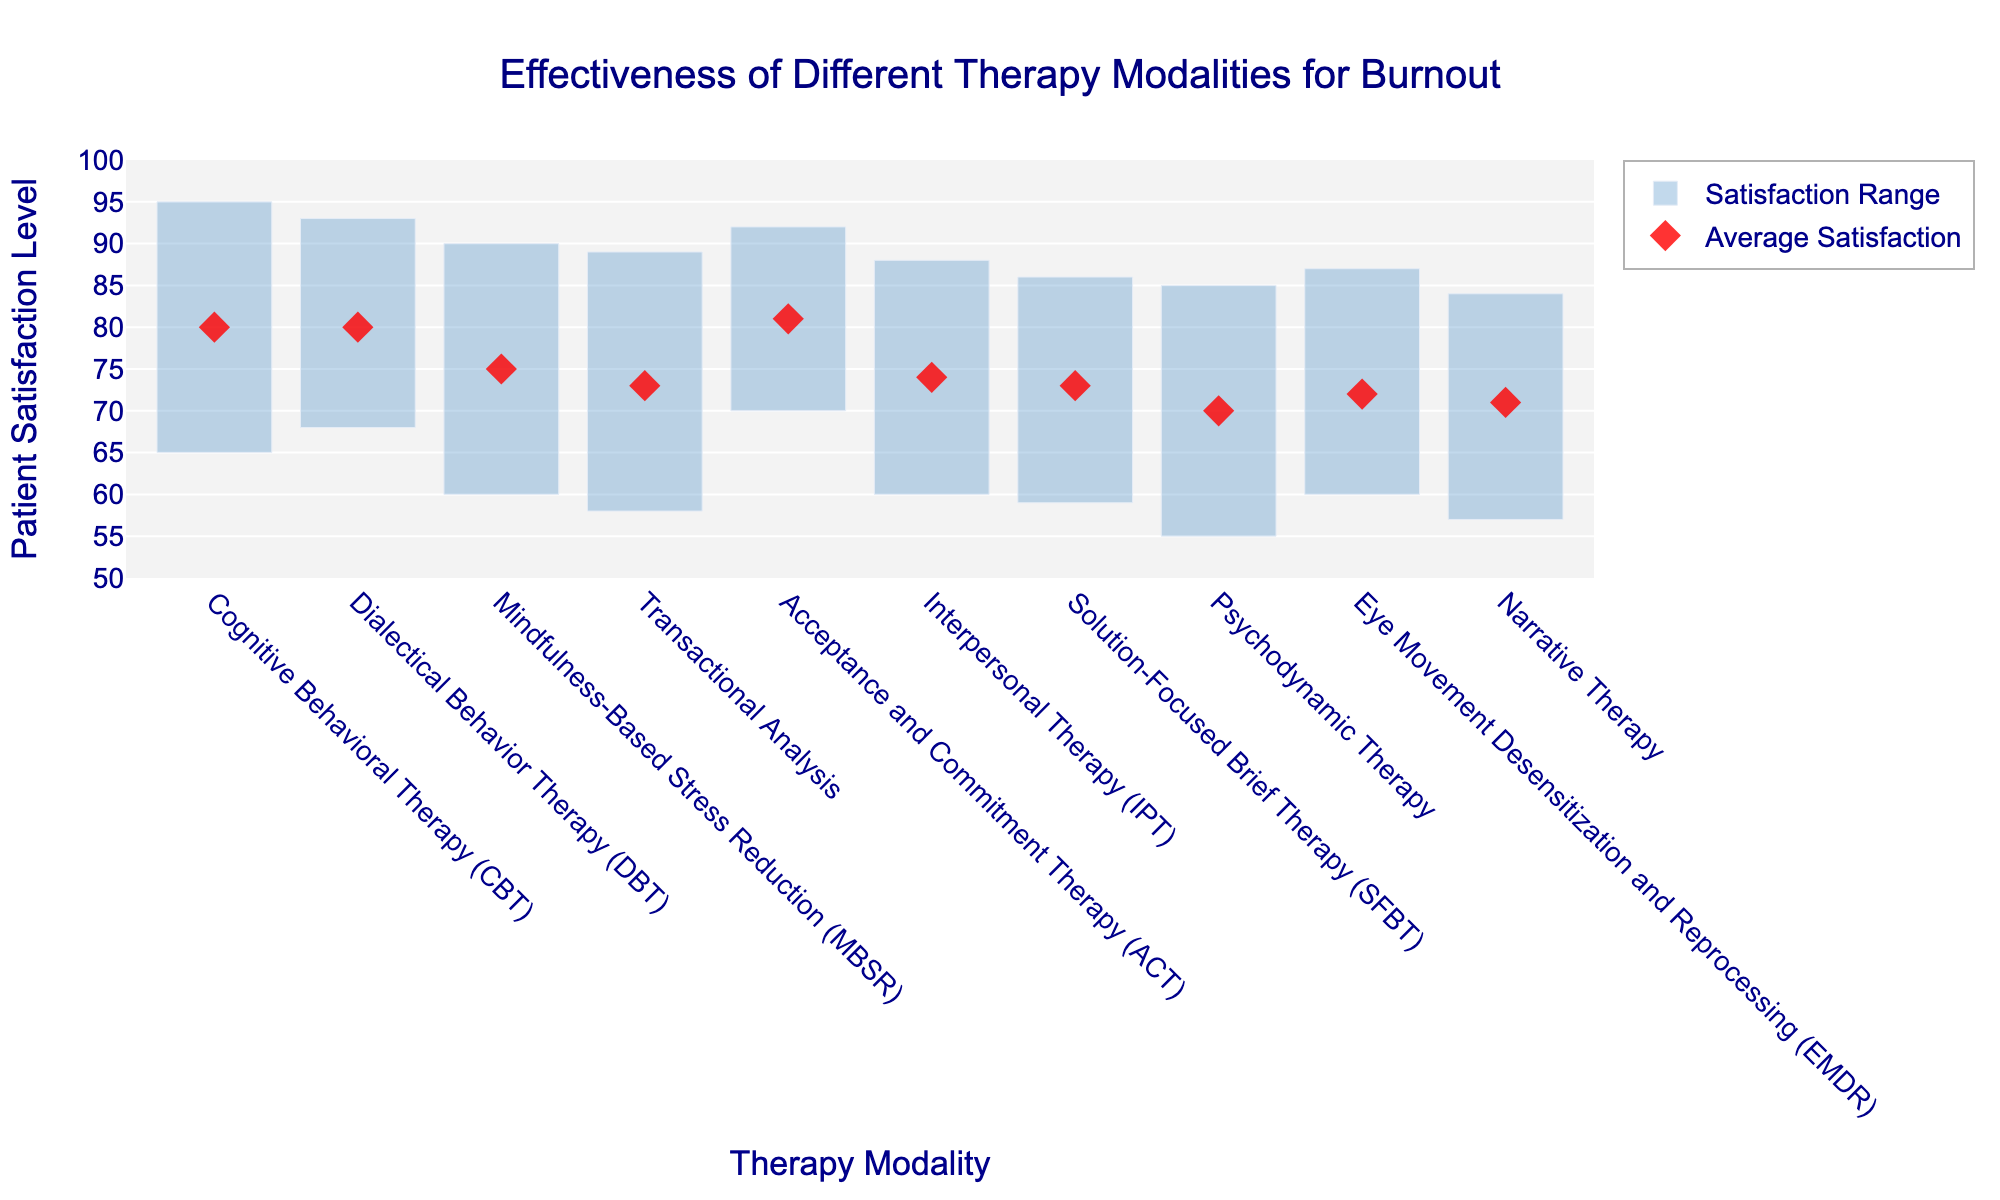what is the highest average satisfaction level among the therapy modalities? By looking at the chart, we can identify the therapy modality with the highest average satisfaction marker (red diamond). The highest average satisfaction level is associated with Acceptance and Commitment Therapy (ACT).
Answer: 81 What therapy modality has the widest range of patient satisfaction levels? The range of patient satisfaction levels is represented by the span of the blue bars. The widest range can be discerned by identifying the therapy with the longest bar. Mindfulness-Based Stress Reduction (MBSR) has the widest range of satisfaction levels.
Answer: Mindfulness-Based Stress Reduction (MBSR) Which therapy modality has the lowest minimum satisfaction level? The minimum satisfaction level is marked by the bottom of the blue bar for each therapy. The therapy with the lowest minimum satisfaction level is Psychodynamic Therapy with a minimum of 55.
Answer: Psychodynamic Therapy How does Cognitive Behavioral Therapy (CBT)’s average satisfaction compare to Interpersonal Therapy (IPT)’s average satisfaction? We locate the average satisfaction markers (red diamonds) for both Cognitive Behavioral Therapy (CBT) and Interpersonal Therapy (IPT). CBT has an average satisfaction level of 80, whereas IPT has an average satisfaction level of 74. Thus, CBT's average satisfaction is higher.
Answer: CBT's average is higher What is the difference between the maximum satisfaction levels of Dialectical Behavior Therapy (DBT) and Solution-Focused Brief Therapy (SFBT)? By examining the top of the blue bars, we find the maximum satisfaction levels: DBT is at 93 and SFBT is at 86. The difference between them is calculated as 93 - 86.
Answer: 7 Which therapy modalities have an average satisfaction level equal to 80? Average satisfaction levels are indicated by the red diamond markers. The therapies with a red diamond at the level 80 are Cognitive Behavioral Therapy (CBT) and Dialectical Behavior Therapy (DBT).
Answer: CBT and DBT What is the satisfaction range for Transactional Analysis? Find the bottom and top of the blue bar for Transactional Analysis; the min satisfaction is 58 and the max is 89. The range is calculated as 89 - 58.
Answer: 31 How many therapy modalities have a maximum satisfaction level of 90 or above? We count the number of therapy modalities with the top of their blue bars at or above the 90 level. These are Cognitive Behavioral Therapy (CBT), Acceptance and Commitment Therapy (ACT), Dialectical Behavior Therapy (DBT), and Mindfulness-Based Stress Reduction (MBSR). Four modalities meet this criterion.
Answer: 4 Which therapy modality has the narrowest range of patient satisfaction levels? We identify the therapy modality with the shortest blue bar. Acceptance and Commitment Therapy (ACT) has the narrowest range.
Answer: Acceptance and Commitment Therapy (ACT) By how much does the average satisfaction level of Narrative Therapy differ from that of Eye Movement Desensitization and Reprocessing (EMDR)? Locate the average satisfaction markers (red diamonds) for both therapies; Narrative Therapy has an average of 71 and EMDR has an average of 72. The difference is calculated as 72 - 71.
Answer: 1 